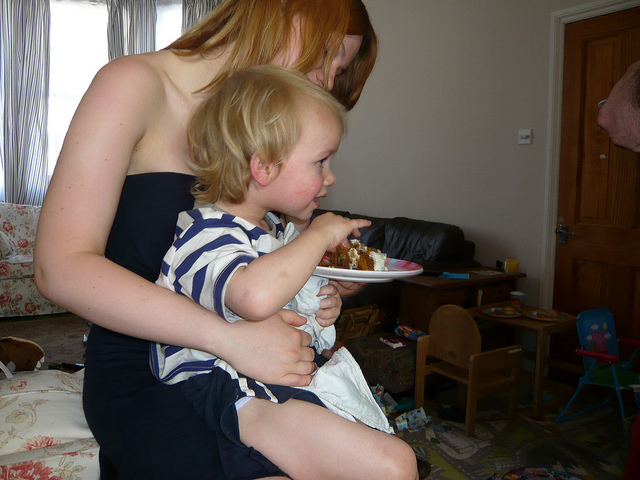<image>What pattern is on the girl's shirt? I am not sure about the pattern on the girl's shirt. It can be stripes, solid, or none. What pattern is on the girl's shirt? I am not sure what pattern is on the girl's shirt. It can be either stripped, stripes, solid or nothing. 